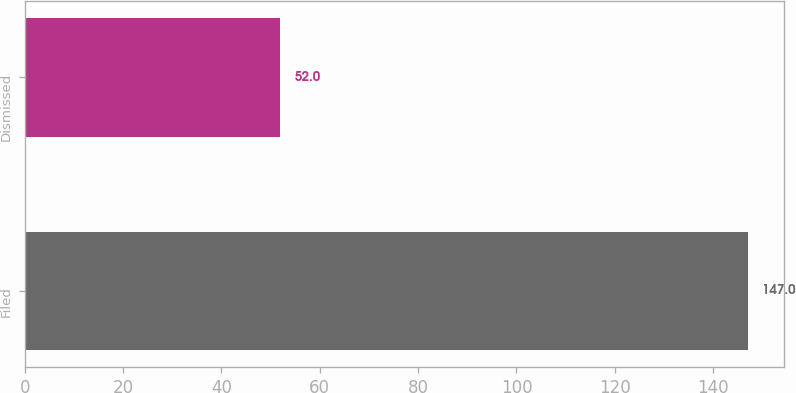Convert chart to OTSL. <chart><loc_0><loc_0><loc_500><loc_500><bar_chart><fcel>Filed<fcel>Dismissed<nl><fcel>147<fcel>52<nl></chart> 